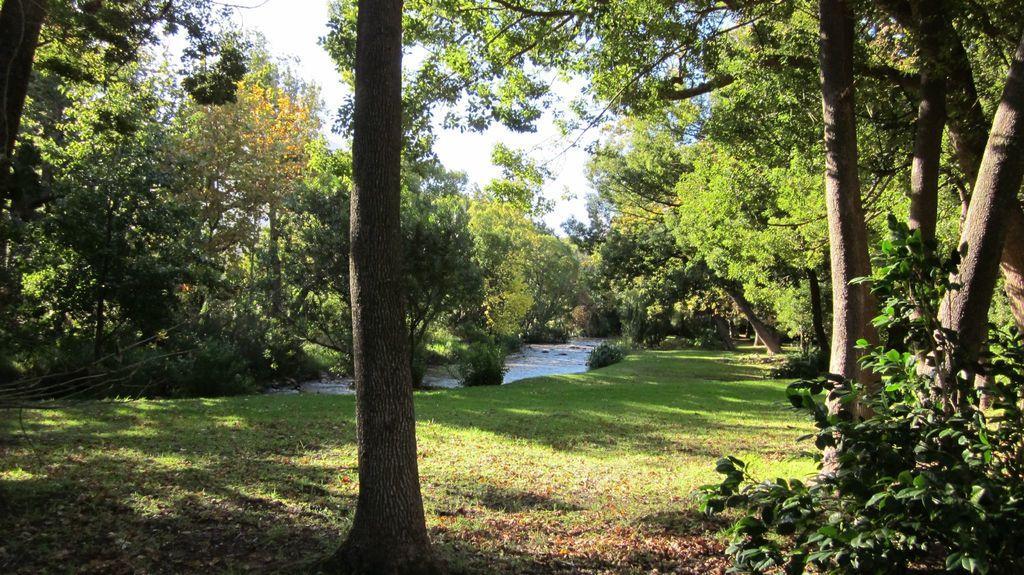Please provide a concise description of this image. In this picture we can see some trees here, at the bottom there is grass, we can see water here, there is the sky at the top of the picture. 